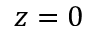<formula> <loc_0><loc_0><loc_500><loc_500>z = 0</formula> 